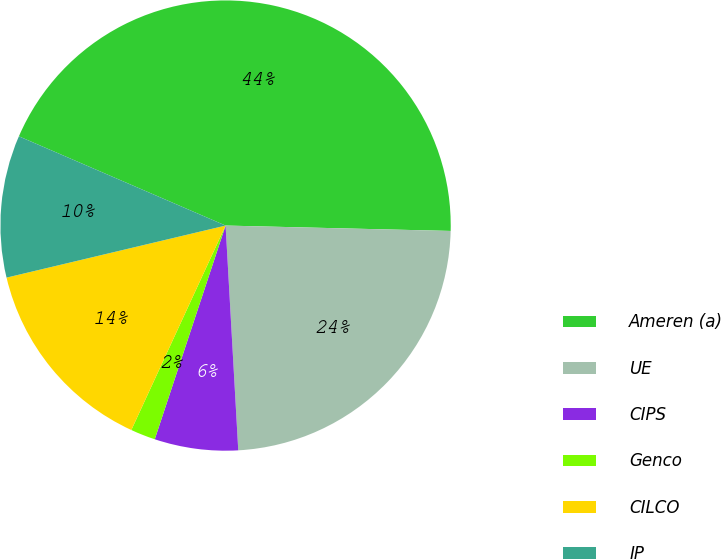Convert chart. <chart><loc_0><loc_0><loc_500><loc_500><pie_chart><fcel>Ameren (a)<fcel>UE<fcel>CIPS<fcel>Genco<fcel>CILCO<fcel>IP<nl><fcel>43.89%<fcel>23.72%<fcel>5.99%<fcel>1.78%<fcel>14.41%<fcel>10.2%<nl></chart> 